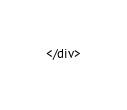<code> <loc_0><loc_0><loc_500><loc_500><_XML_></div>
</code> 